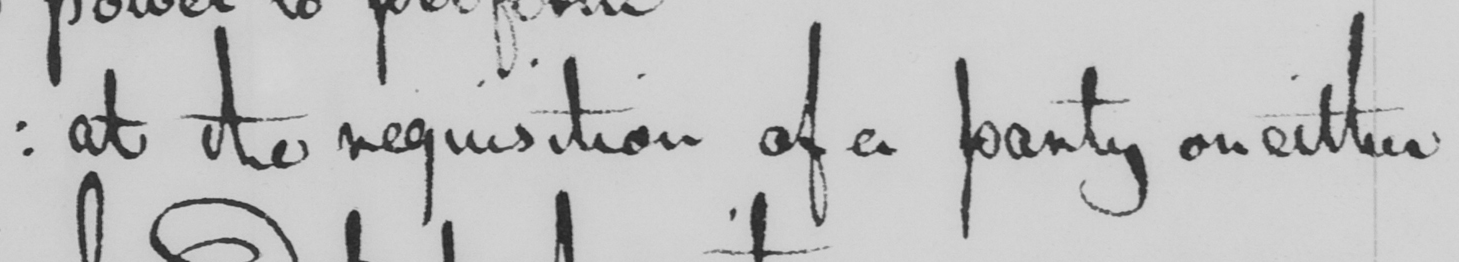Can you tell me what this handwritten text says? :  at the requisition of a party on either 